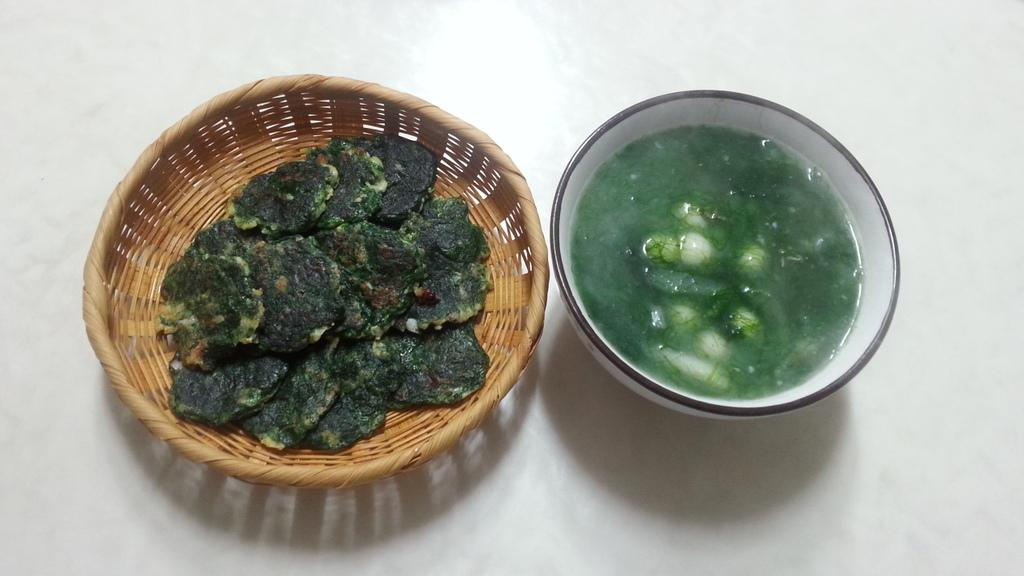What type of food can be seen in the basket in the image? The facts do not specify the type of food in the basket. What is the second type of food visible in the image? There is a bowl of soup in the image. On what surface is the bowl of soup placed? The bowl of soup is placed on a white surface. What color is the curtain hanging behind the bowl of soup in the image? There is no curtain present in the image. What subject is being taught in the image? The image does not depict any teaching or educational activity. Is there a whip visible in the image? There is no whip present in the image. 